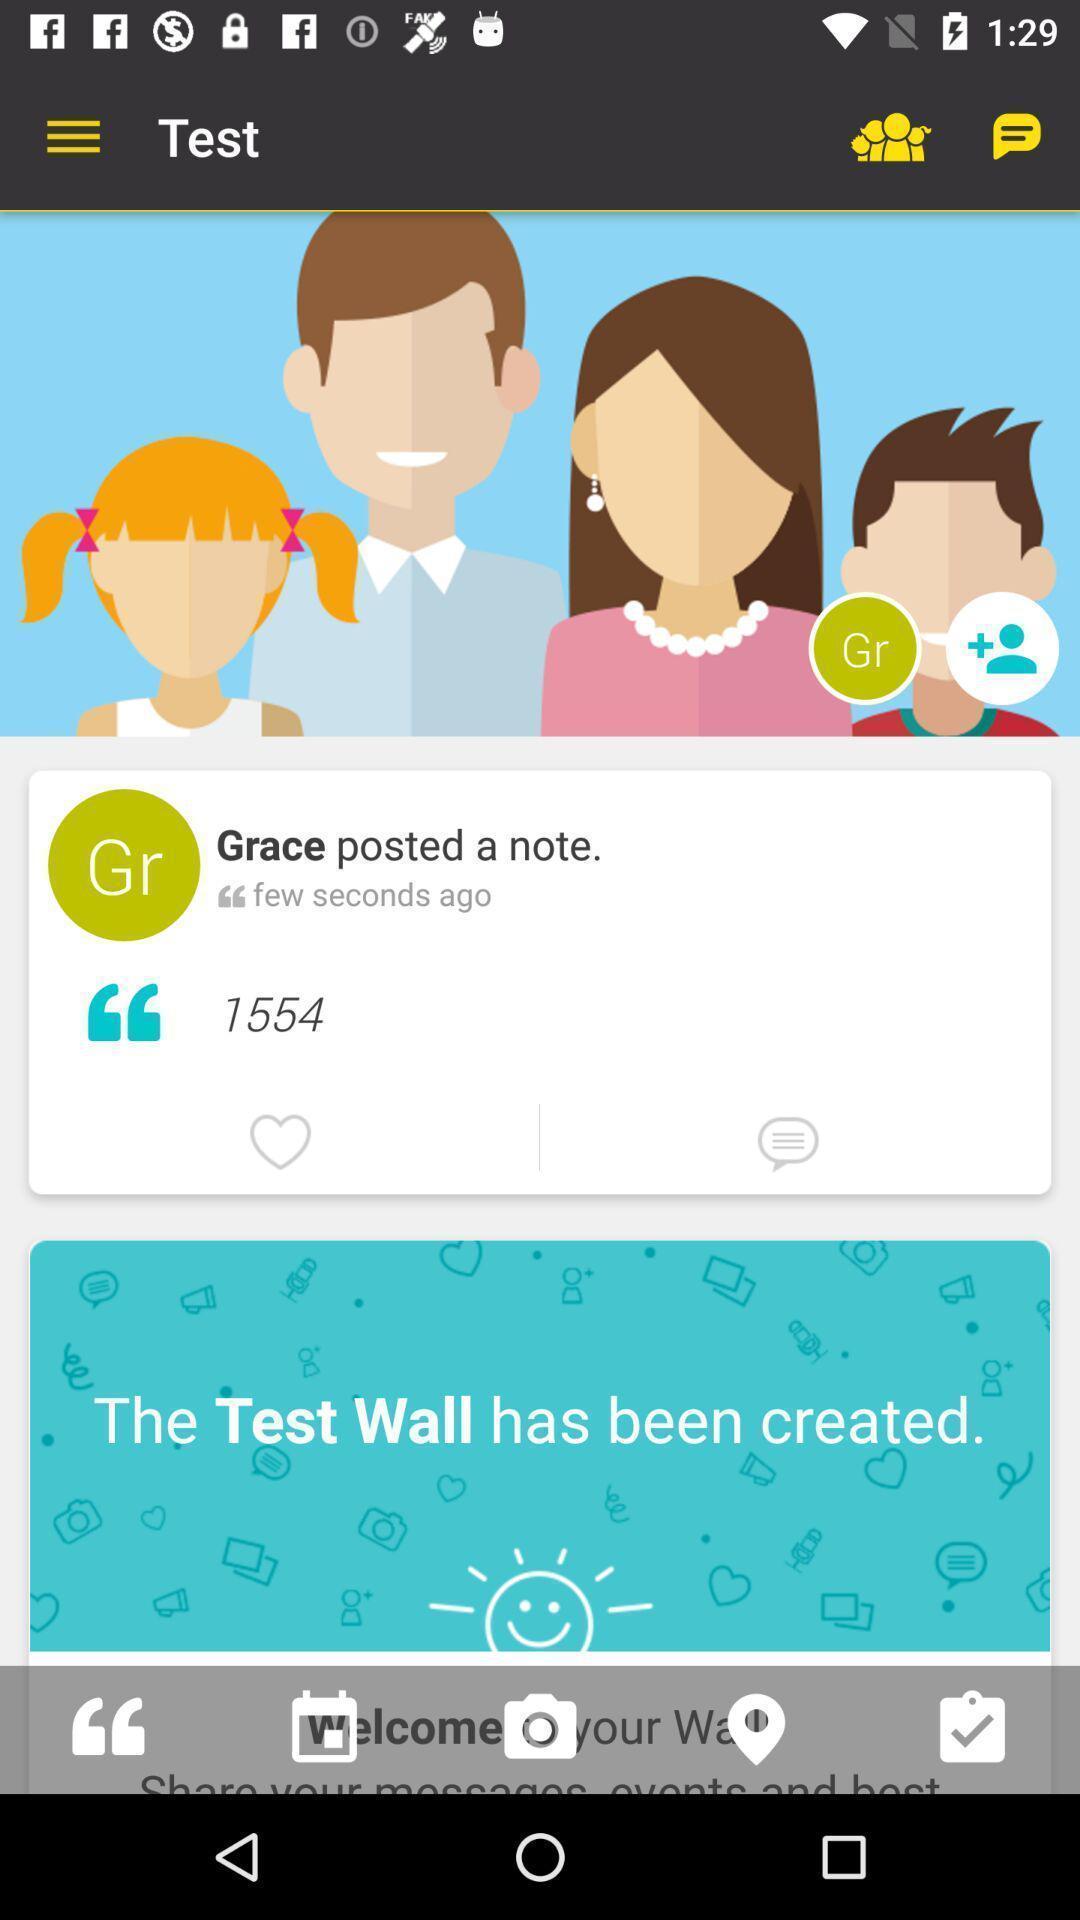Provide a description of this screenshot. Page displaying with posts and few options. 